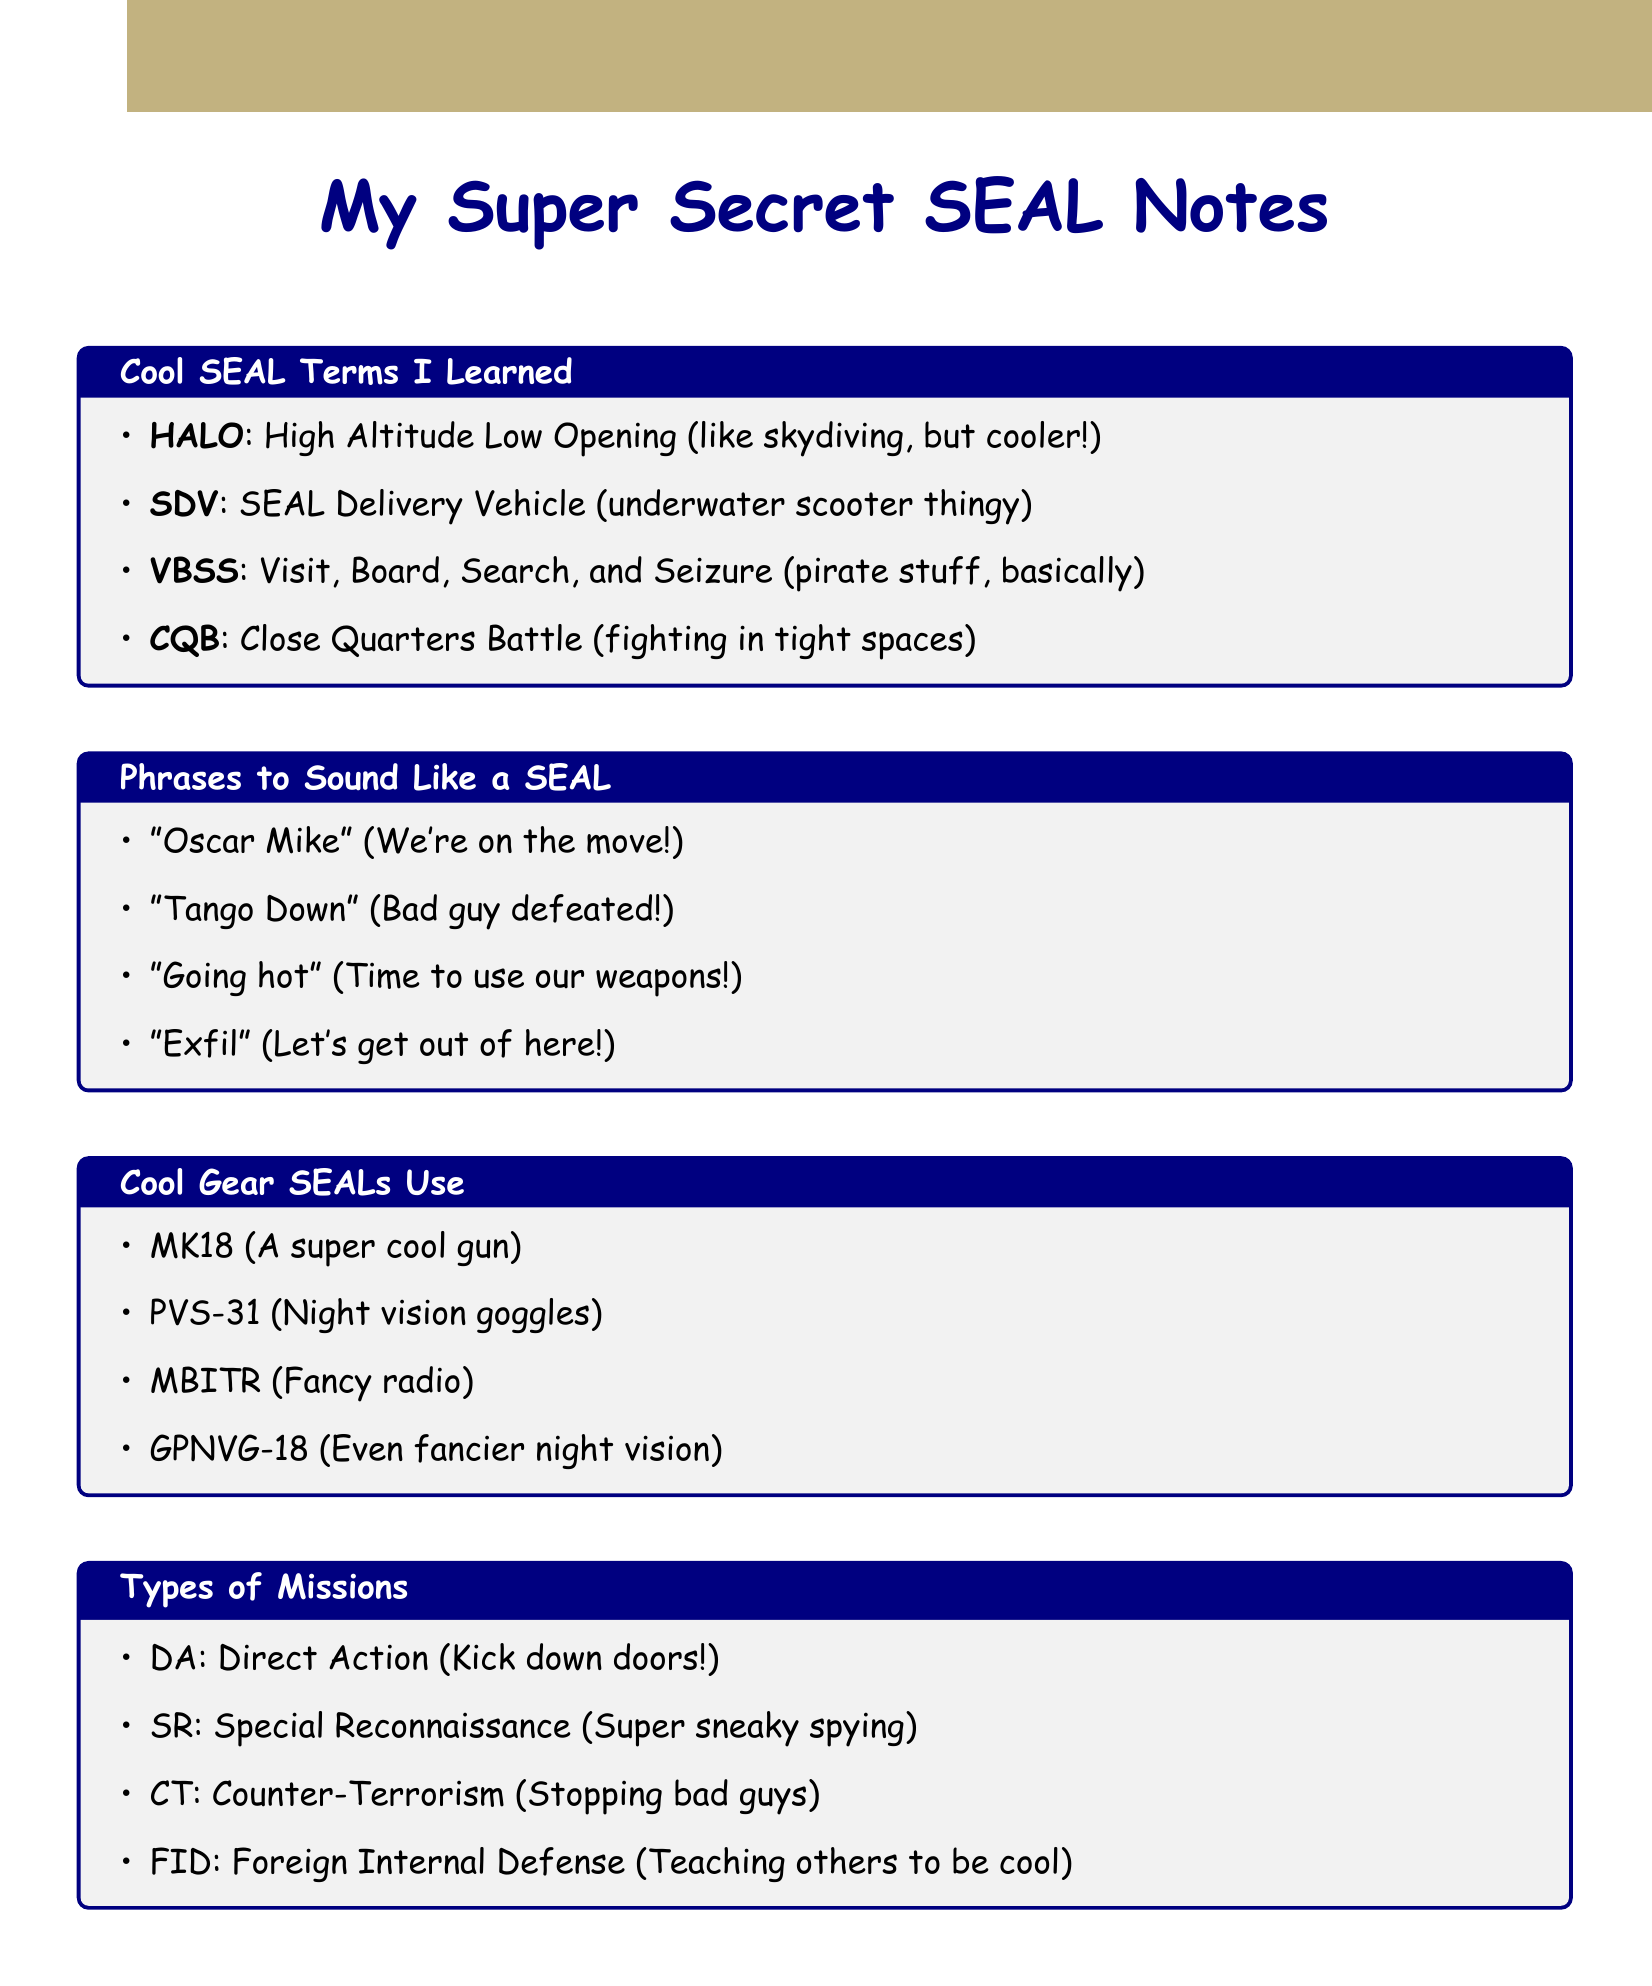What does HALO stand for? HALO is defined in the document as High Altitude Low Opening, which is a parachuting technique.
Answer: High Altitude Low Opening What does SDV refer to? The abbreviation SDV in the document stands for SEAL Delivery Vehicle, which is a manned submersible.
Answer: SEAL Delivery Vehicle What does VBSS entail? VBSS is outlined in the notes as Visit, Board, Search, and Seizure, which describes a maritime operation.
Answer: Visit, Board, Search, and Seizure Which phrase means "We're on the move"? The phrase "Oscar Mike" is provided in the document and means "We're on the move."
Answer: Oscar Mike List one type of mission mentioned in the document. The document lists various mission types, one of which is Direct Action (DA).
Answer: Direct Action What equipment is referred to as night vision goggles? The document mentions PVS-31 as night vision goggles used by SEALs.
Answer: PVS-31 Why should stories focus on teamwork? The writing tips suggest focusing on teamwork and camaraderie to highlight essential aspects of SEAL operations.
Answer: Teamwork and camaraderie What is a common equipment acronym used by SEALs? The document provides several acronyms, such as MBITR, which stands for Multi-band radio.
Answer: MBITR What does "going hot" mean? In the context of the document, "going hot" means weapons are free to use.
Answer: Weapons free 